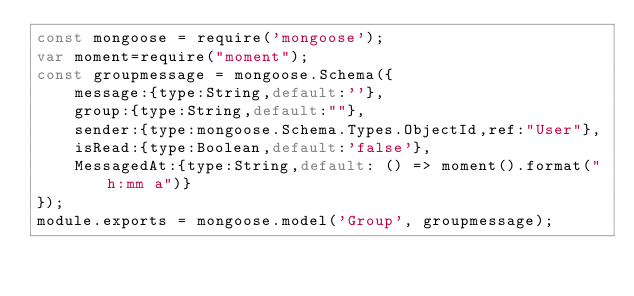Convert code to text. <code><loc_0><loc_0><loc_500><loc_500><_JavaScript_>const mongoose = require('mongoose');
var moment=require("moment");
const groupmessage = mongoose.Schema({
    message:{type:String,default:''},
    group:{type:String,default:""},
    sender:{type:mongoose.Schema.Types.ObjectId,ref:"User"},
    isRead:{type:Boolean,default:'false'},
    MessagedAt:{type:String,default: () => moment().format("h:mm a")}
});
module.exports = mongoose.model('Group', groupmessage);</code> 